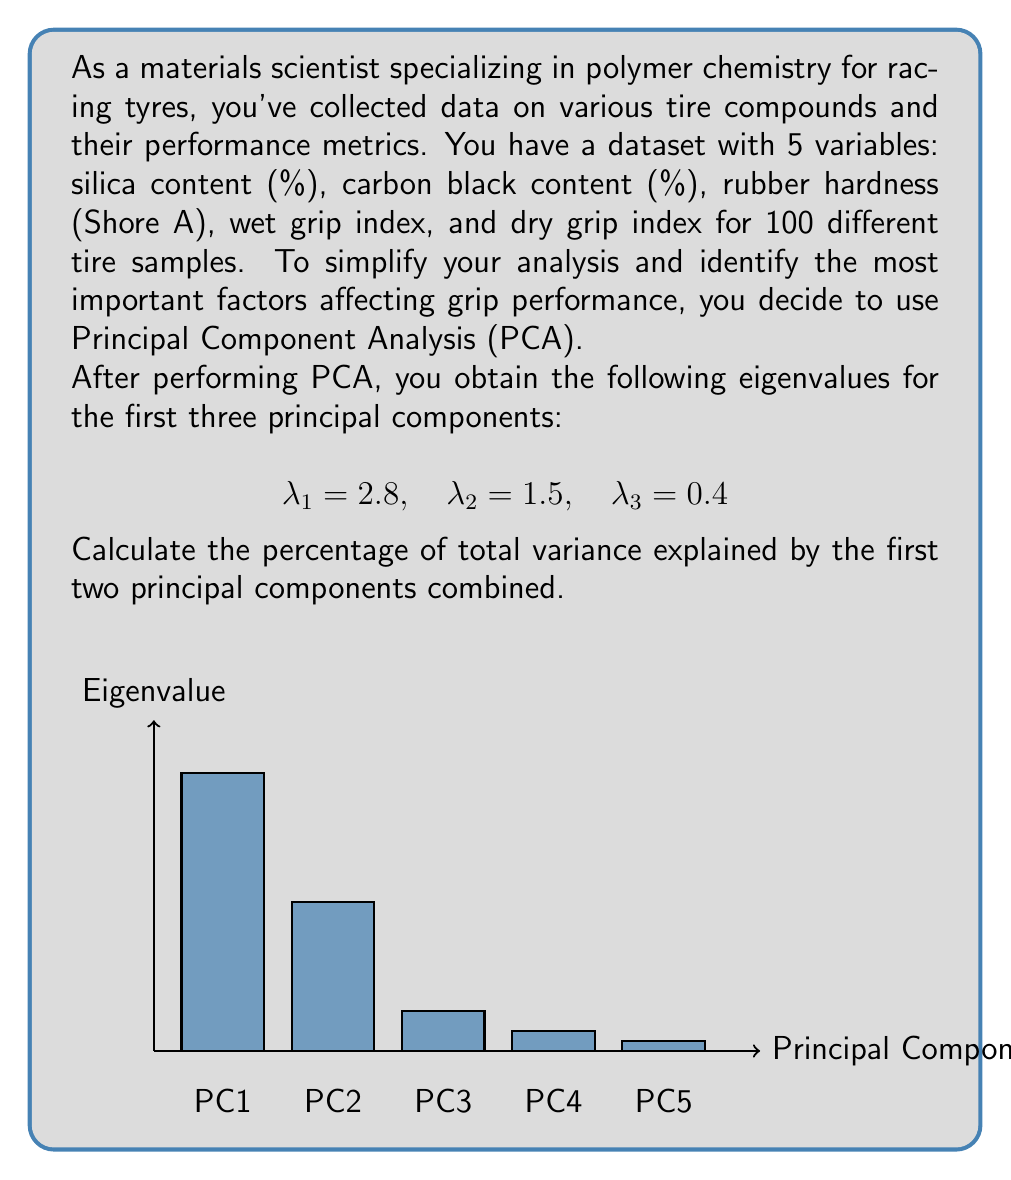Could you help me with this problem? To solve this problem, we'll follow these steps:

1. Calculate the total variance:
   The total variance is the sum of all eigenvalues. In PCA, each eigenvalue represents the amount of variance explained by its corresponding principal component.

   $$\text{Total Variance} = \sum_{i=1}^5 \lambda_i = 2.8 + 1.5 + 0.4 + 0.2 + 0.1 = 5$$

2. Calculate the variance explained by the first two principal components:
   $$\text{Variance Explained} = \lambda_1 + \lambda_2 = 2.8 + 1.5 = 4.3$$

3. Calculate the percentage of total variance explained:
   $$\text{Percentage} = \frac{\text{Variance Explained}}{\text{Total Variance}} \times 100\%$$
   
   $$\text{Percentage} = \frac{4.3}{5} \times 100\% = 0.86 \times 100\% = 86\%$$

Therefore, the first two principal components combined explain 86% of the total variance in the dataset.

This high percentage indicates that these two components capture most of the important information in your tire grip performance data, allowing you to focus on these factors for further analysis and optimization of tire compounds.
Answer: 86% 